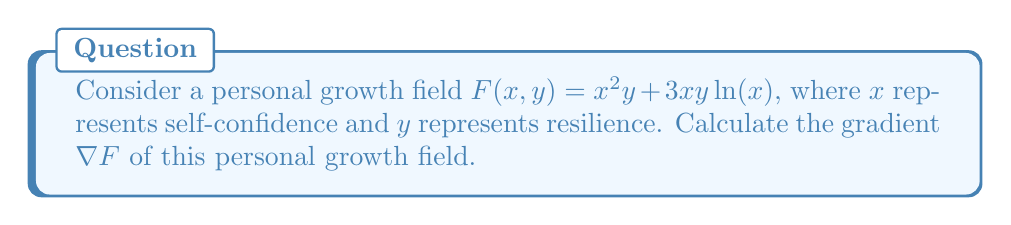Could you help me with this problem? To calculate the gradient of the personal growth field, we need to find the partial derivatives of $F$ with respect to $x$ and $y$.

Step 1: Calculate $\frac{\partial F}{\partial x}$
$$\begin{align}
\frac{\partial F}{\partial x} &= \frac{\partial}{\partial x}(x^2y + 3xy\ln(x)) \\
&= 2xy + 3y\ln(x) + 3y\frac{1}{x}x \\
&= 2xy + 3y\ln(x) + 3y
\end{align}$$

Step 2: Calculate $\frac{\partial F}{\partial y}$
$$\begin{align}
\frac{\partial F}{\partial y} &= \frac{\partial}{\partial y}(x^2y + 3xy\ln(x)) \\
&= x^2 + 3x\ln(x)
\end{align}$$

Step 3: Combine the partial derivatives to form the gradient
The gradient is defined as:
$$\nabla F = \left(\frac{\partial F}{\partial x}, \frac{\partial F}{\partial y}\right)$$

Substituting our results from steps 1 and 2:
$$\nabla F = (2xy + 3y\ln(x) + 3y, x^2 + 3x\ln(x))$$
Answer: $\nabla F = (2xy + 3y\ln(x) + 3y, x^2 + 3x\ln(x))$ 